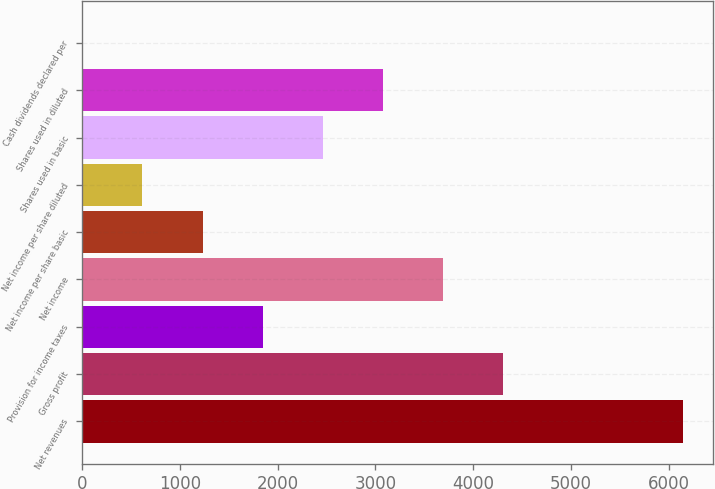<chart> <loc_0><loc_0><loc_500><loc_500><bar_chart><fcel>Net revenues<fcel>Gross profit<fcel>Provision for income taxes<fcel>Net income<fcel>Net income per share basic<fcel>Net income per share diluted<fcel>Shares used in basic<fcel>Shares used in diluted<fcel>Cash dividends declared per<nl><fcel>6146<fcel>4302.68<fcel>1844.92<fcel>3688.24<fcel>1230.48<fcel>616.04<fcel>2459.36<fcel>3073.8<fcel>1.6<nl></chart> 